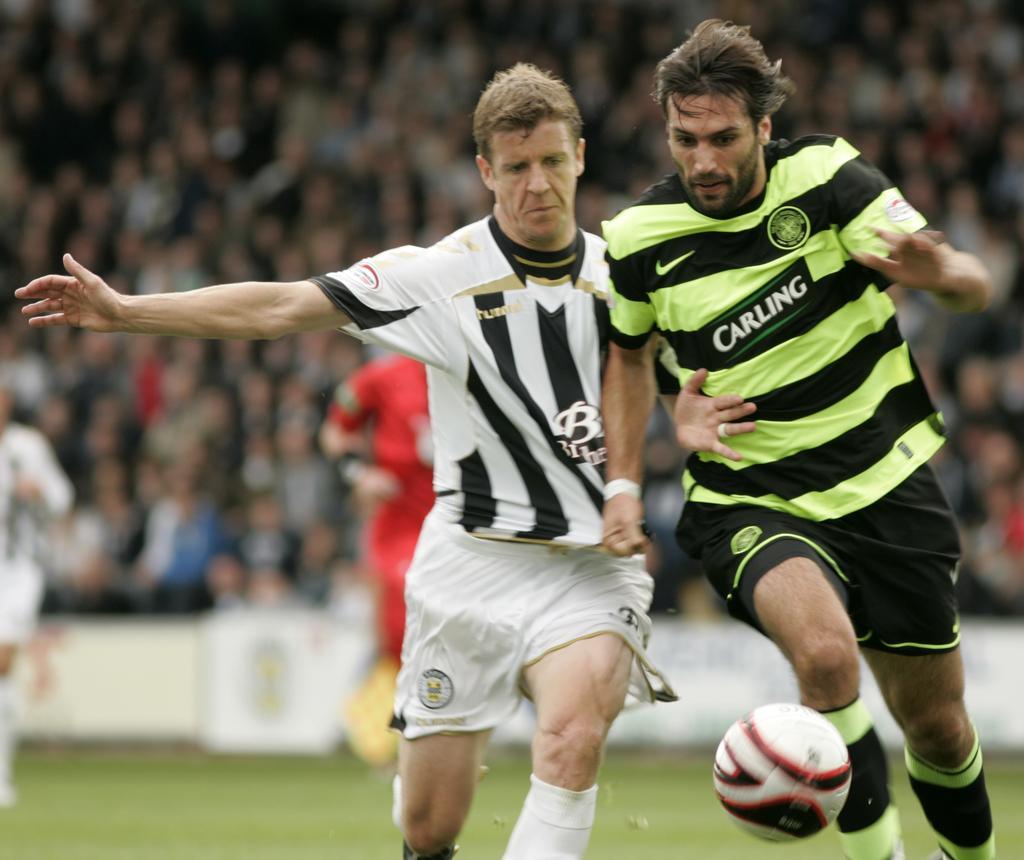How would you summarize this image in a sentence or two? In this image there are two football players wearing green color dress and white color dress and at the bottom of the image there is a ball. 